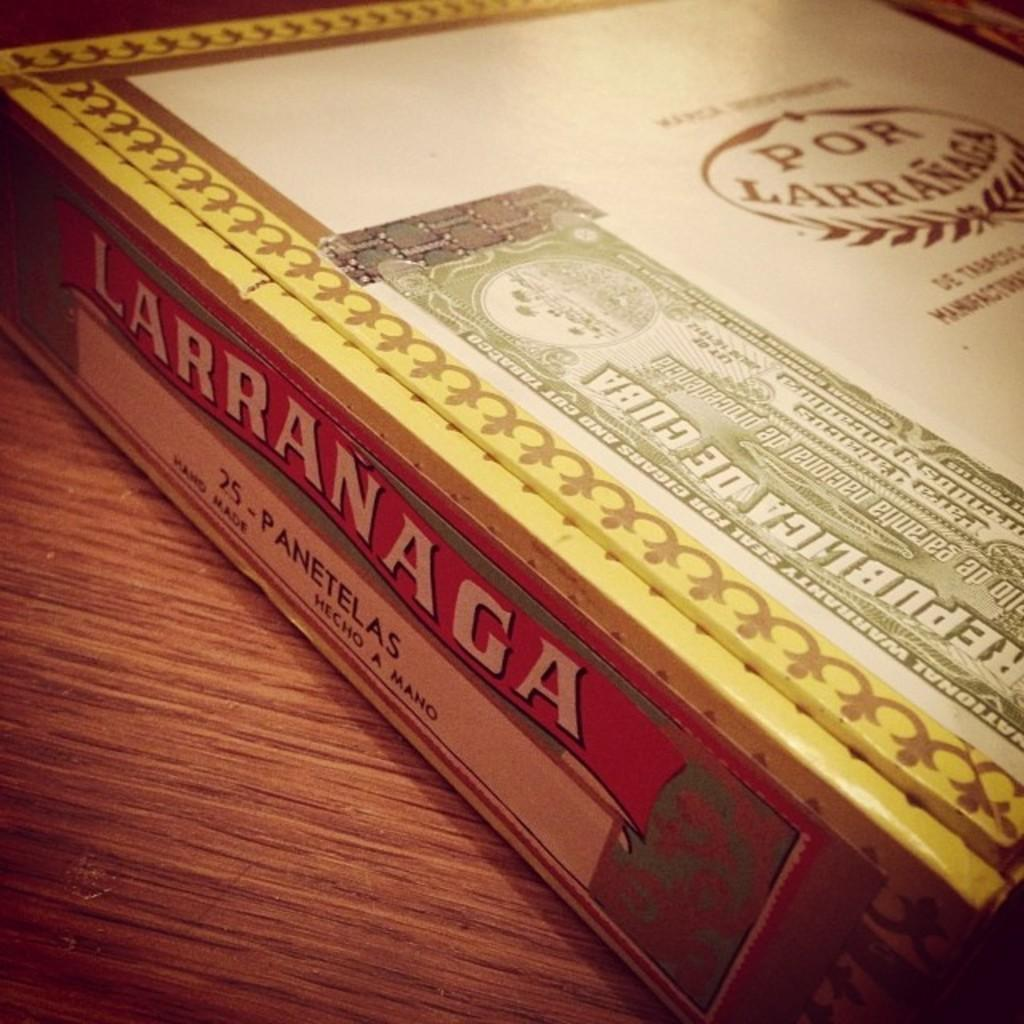<image>
Present a compact description of the photo's key features. A cover with the word Larranaga on the side. 